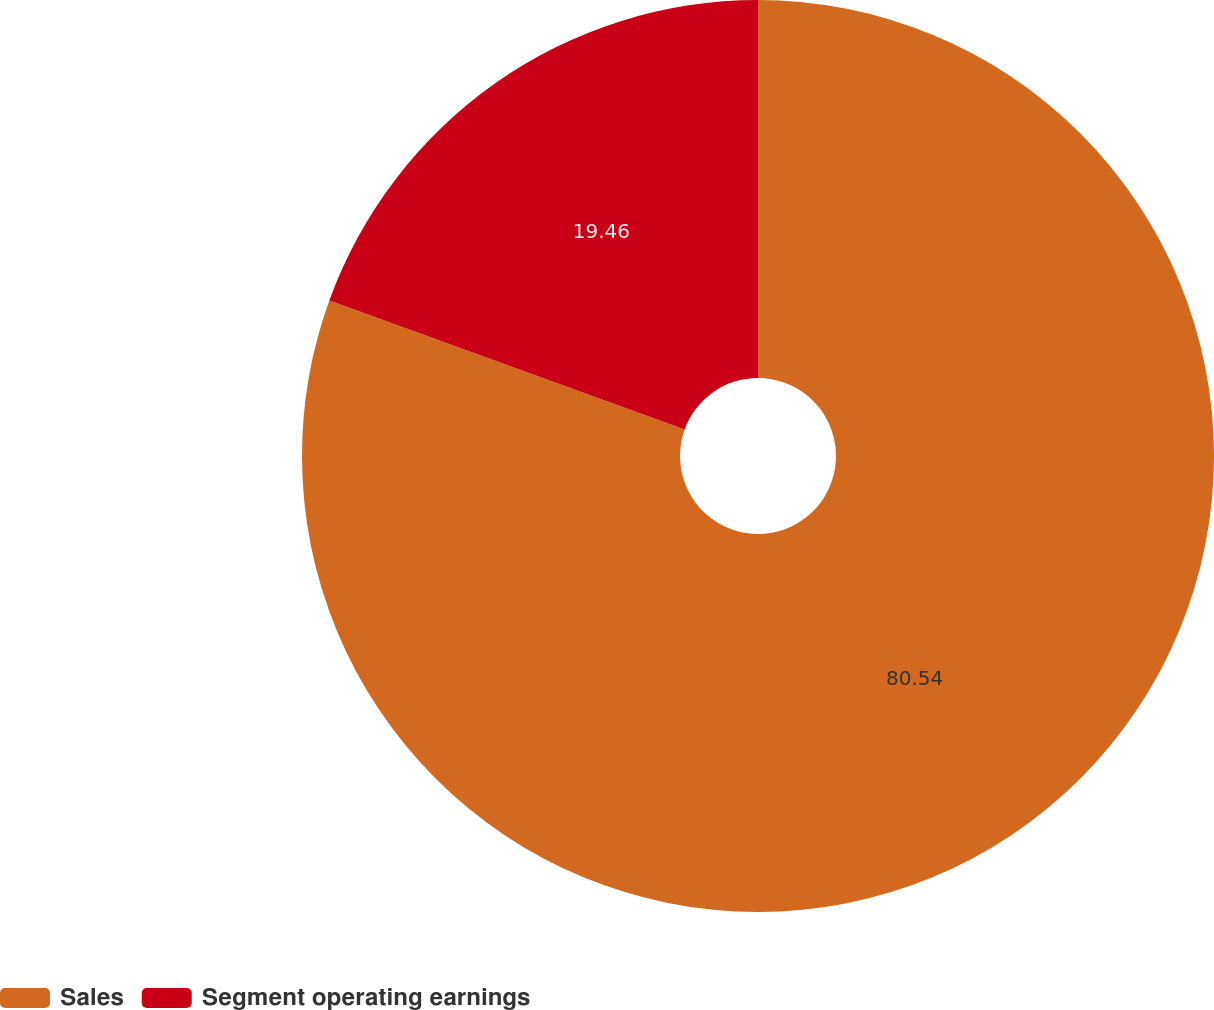<chart> <loc_0><loc_0><loc_500><loc_500><pie_chart><fcel>Sales<fcel>Segment operating earnings<nl><fcel>80.54%<fcel>19.46%<nl></chart> 